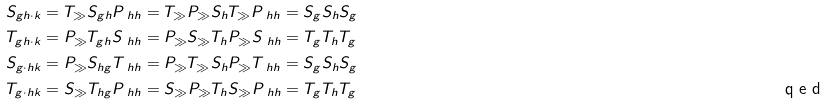<formula> <loc_0><loc_0><loc_500><loc_500>S _ { g h \cdot k } & = T _ { \gg } S _ { g h } P _ { \ h h } = T _ { \gg } P _ { \gg } S _ { h } T _ { \gg } P _ { \ h h } = S _ { g } S _ { h } S _ { g } \\ T _ { g h \cdot k } & = P _ { \gg } T _ { g h } S _ { \ h h } = P _ { \gg } S _ { \gg } T _ { h } P _ { \gg } S _ { \ h h } = T _ { g } T _ { h } T _ { g } \\ S _ { g \cdot h k } & = P _ { \gg } S _ { h g } T _ { \ h h } = P _ { \gg } T _ { \gg } S _ { h } P _ { \gg } T _ { \ h h } = S _ { g } S _ { h } S _ { g } \\ T _ { g \cdot h k } & = S _ { \gg } T _ { h g } P _ { \ h h } = S _ { \gg } P _ { \gg } T _ { h } S _ { \gg } P _ { \ h h } = T _ { g } T _ { h } T _ { g } \tag* { \ q e d }</formula> 